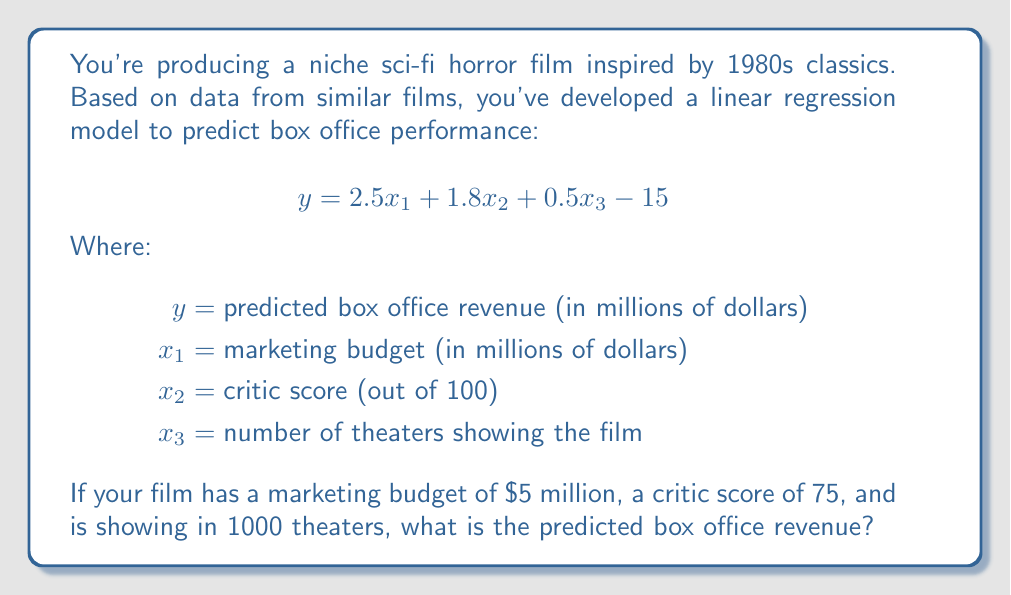Teach me how to tackle this problem. To solve this problem, we'll use the given linear regression model and substitute the values for each variable:

1. First, let's identify our values:
   $x_1 = 5$ (marketing budget in millions)
   $x_2 = 75$ (critic score)
   $x_3 = 1000$ (number of theaters)

2. Now, let's substitute these values into our equation:

   $$y = 2.5x_1 + 1.8x_2 + 0.5x_3 - 15$$

3. Substituting the values:

   $$y = 2.5(5) + 1.8(75) + 0.5(1000) - 15$$

4. Let's solve each part:
   - $2.5(5) = 12.5$
   - $1.8(75) = 135$
   - $0.5(1000) = 500$

5. Now our equation looks like:

   $$y = 12.5 + 135 + 500 - 15$$

6. Adding these together:

   $$y = 647.5 - 15 = 632.5$$

Therefore, the predicted box office revenue is $632.5 million.
Answer: $632.5 million 